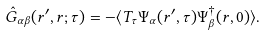<formula> <loc_0><loc_0><loc_500><loc_500>\hat { G } _ { \alpha \beta } ( r ^ { \prime } , r ; \tau ) = - \langle T _ { \tau } \Psi _ { \alpha } ( r ^ { \prime } , \tau ) \Psi _ { \beta } ^ { \dag } ( r , 0 ) \rangle .</formula> 